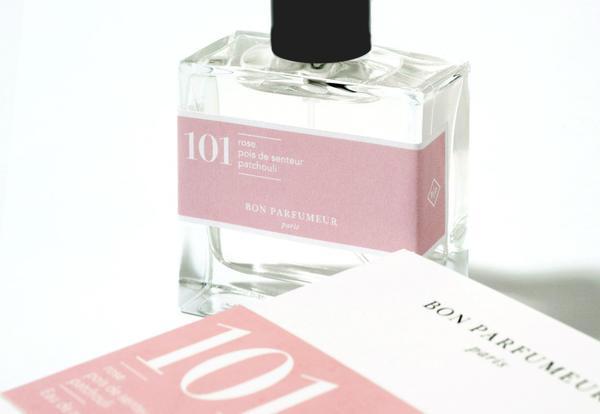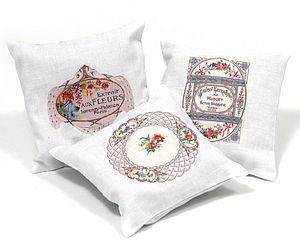The first image is the image on the left, the second image is the image on the right. For the images shown, is this caption "A golden bottle of perfume with a golden chain and black tassel is sitting next to a matching golden box." true? Answer yes or no. No. The first image is the image on the left, the second image is the image on the right. For the images shown, is this caption "there is a perfume container with a chain and tassles" true? Answer yes or no. No. 